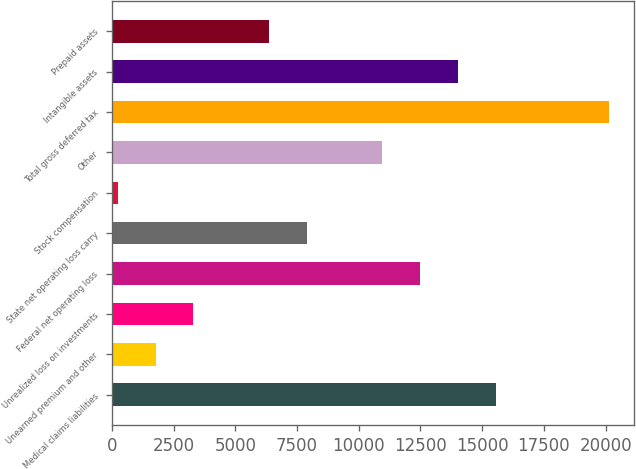Convert chart. <chart><loc_0><loc_0><loc_500><loc_500><bar_chart><fcel>Medical claims liabilities<fcel>Unearned premium and other<fcel>Unrealized loss on investments<fcel>Federal net operating loss<fcel>State net operating loss carry<fcel>Stock compensation<fcel>Other<fcel>Total gross deferred tax<fcel>Intangible assets<fcel>Prepaid assets<nl><fcel>15551<fcel>1773.8<fcel>3304.6<fcel>12489.4<fcel>7897<fcel>243<fcel>10958.6<fcel>20143.4<fcel>14020.2<fcel>6366.2<nl></chart> 